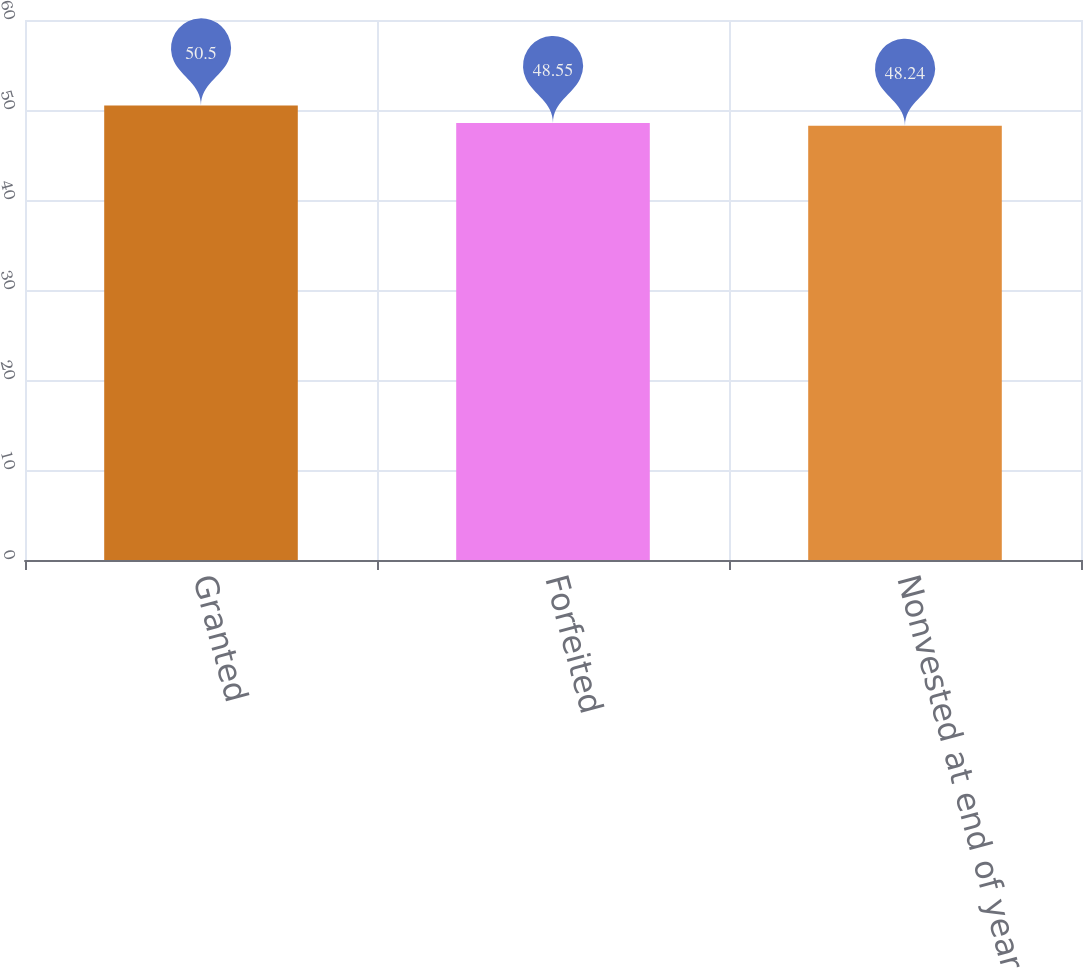<chart> <loc_0><loc_0><loc_500><loc_500><bar_chart><fcel>Granted<fcel>Forfeited<fcel>Nonvested at end of year<nl><fcel>50.5<fcel>48.55<fcel>48.24<nl></chart> 